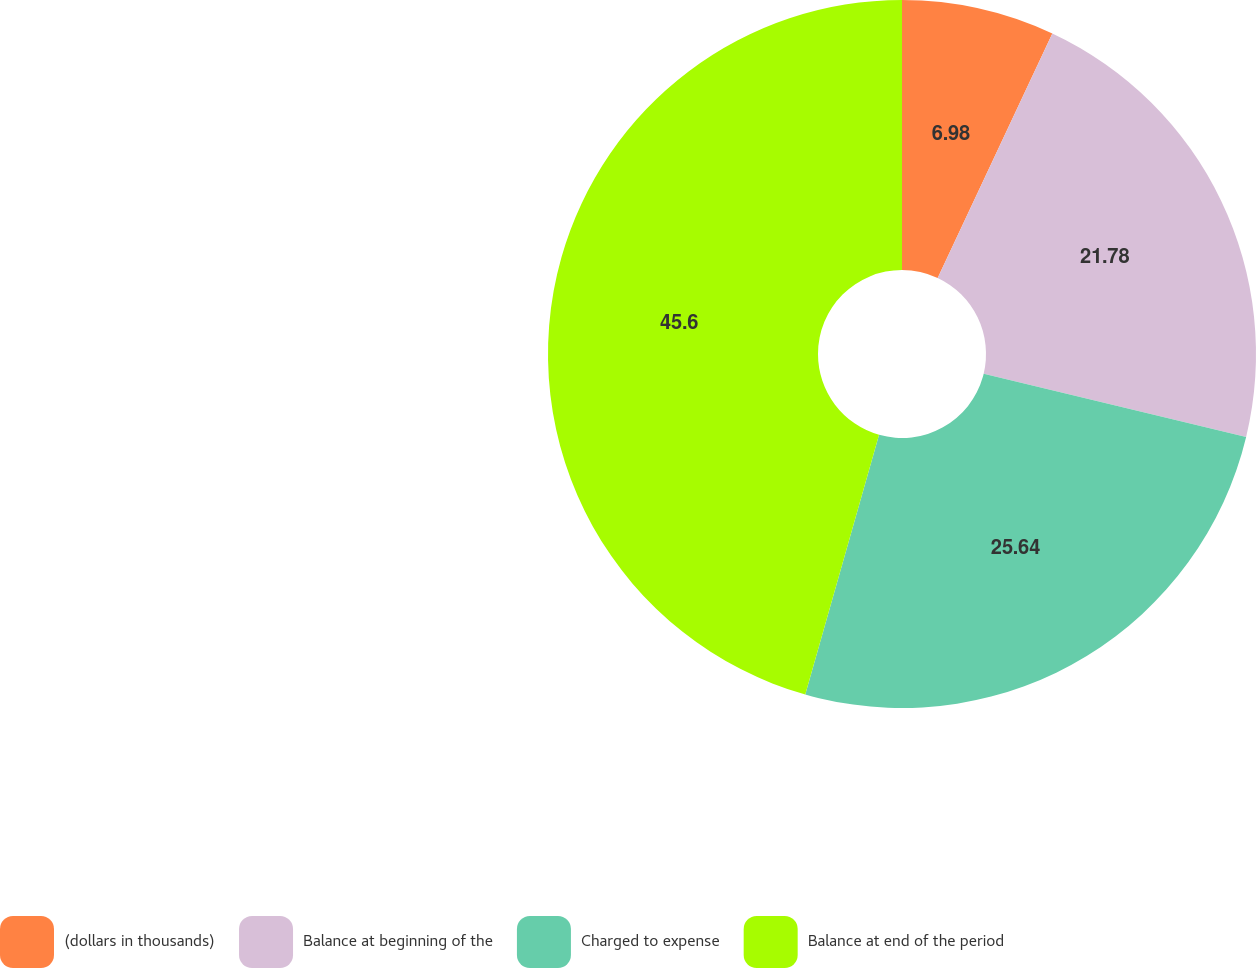<chart> <loc_0><loc_0><loc_500><loc_500><pie_chart><fcel>(dollars in thousands)<fcel>Balance at beginning of the<fcel>Charged to expense<fcel>Balance at end of the period<nl><fcel>6.98%<fcel>21.78%<fcel>25.64%<fcel>45.59%<nl></chart> 